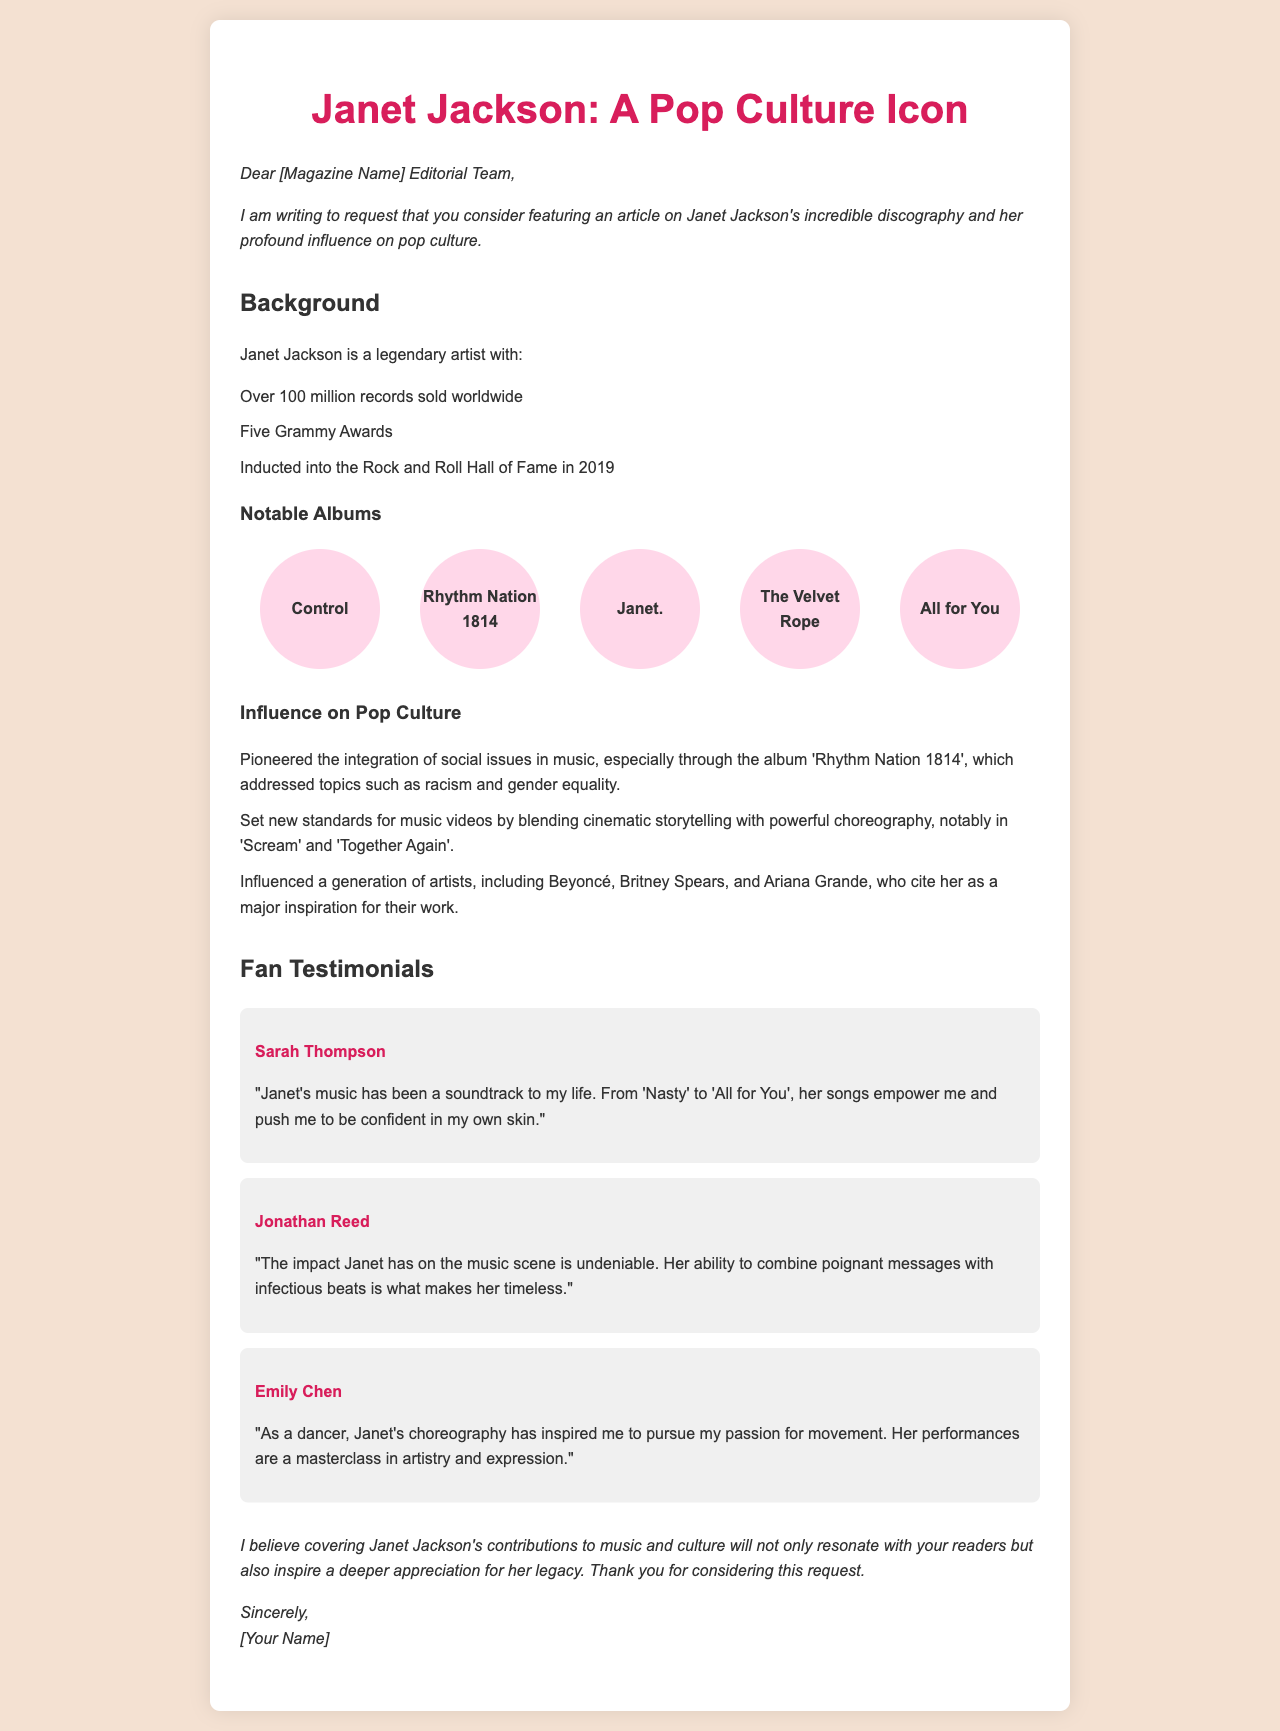What is the name of the artist featured in the letter? The letter specifically requests coverage for Janet Jackson and discusses her influence on pop culture.
Answer: Janet Jackson How many Grammy Awards has Janet Jackson won? The letter mentions that she has received five Grammy Awards as part of her accolades.
Answer: Five What year was Janet Jackson inducted into the Rock and Roll Hall of Fame? The document states that she was inducted in 2019, which is a significant milestone in her career.
Answer: 2019 Which album addresses social issues like racism and gender equality? 'Rhythm Nation 1814' is highlighted in the document as pioneering the integration of social issues in music.
Answer: Rhythm Nation 1814 Who is a fan that mentioned Janet's music empowers them? Sarah Thompson is quoted in the letter expressing how Janet's music has impacted her confidence and empowerment.
Answer: Sarah Thompson What do the testimonials in the letter highlight? The testimonials collectively emphasize the personal and cultural impact that Janet Jackson's music and artistry have had on her fans.
Answer: Personal and cultural impact How many notable albums are listed in the document? The document provides a list of five notable albums that showcase Janet Jackson's contributions to music.
Answer: Five 